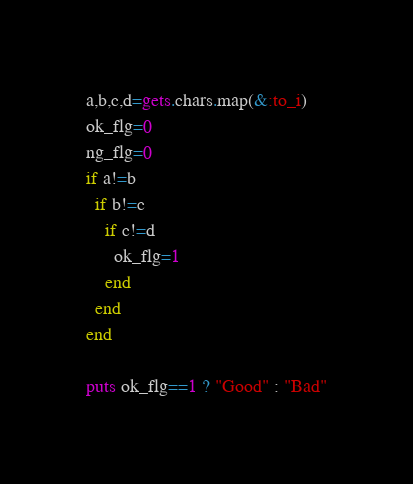Convert code to text. <code><loc_0><loc_0><loc_500><loc_500><_Ruby_>a,b,c,d=gets.chars.map(&:to_i)
ok_flg=0
ng_flg=0
if a!=b
  if b!=c
    if c!=d
      ok_flg=1
    end
  end
end

puts ok_flg==1 ? "Good" : "Bad"</code> 